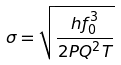Convert formula to latex. <formula><loc_0><loc_0><loc_500><loc_500>\sigma = \sqrt { \frac { h f _ { 0 } ^ { 3 } } { 2 P Q ^ { 2 } T } }</formula> 